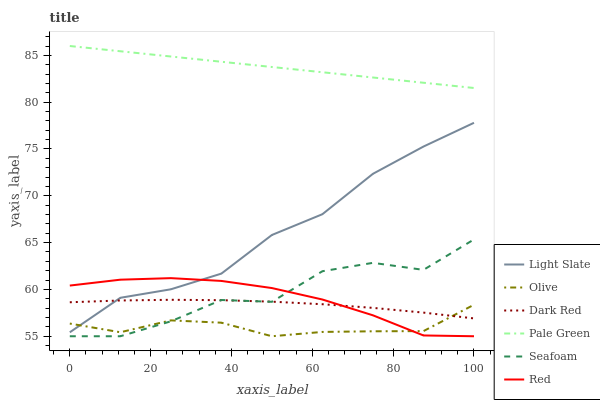Does Olive have the minimum area under the curve?
Answer yes or no. Yes. Does Pale Green have the maximum area under the curve?
Answer yes or no. Yes. Does Dark Red have the minimum area under the curve?
Answer yes or no. No. Does Dark Red have the maximum area under the curve?
Answer yes or no. No. Is Pale Green the smoothest?
Answer yes or no. Yes. Is Seafoam the roughest?
Answer yes or no. Yes. Is Dark Red the smoothest?
Answer yes or no. No. Is Dark Red the roughest?
Answer yes or no. No. Does Seafoam have the lowest value?
Answer yes or no. Yes. Does Dark Red have the lowest value?
Answer yes or no. No. Does Pale Green have the highest value?
Answer yes or no. Yes. Does Dark Red have the highest value?
Answer yes or no. No. Is Dark Red less than Pale Green?
Answer yes or no. Yes. Is Pale Green greater than Dark Red?
Answer yes or no. Yes. Does Dark Red intersect Red?
Answer yes or no. Yes. Is Dark Red less than Red?
Answer yes or no. No. Is Dark Red greater than Red?
Answer yes or no. No. Does Dark Red intersect Pale Green?
Answer yes or no. No. 